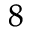<formula> <loc_0><loc_0><loc_500><loc_500>_ { 8 }</formula> 